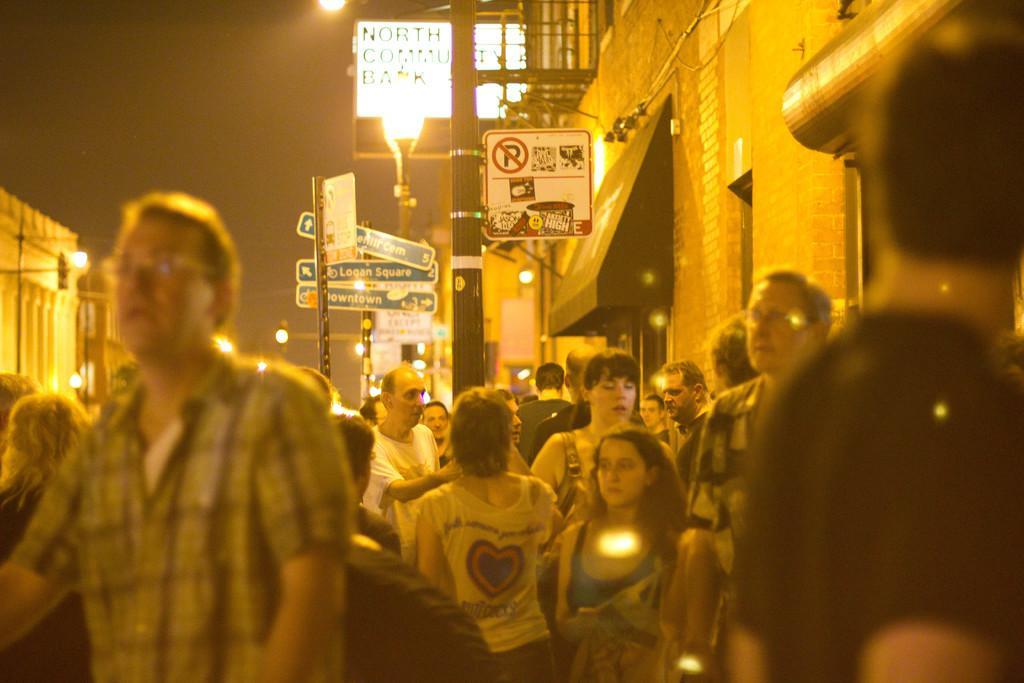How would you summarize this image in a sentence or two? In this image there are a few people walking on the streets and there are sign boards and lampposts, on the either side of the street there are buildings. 